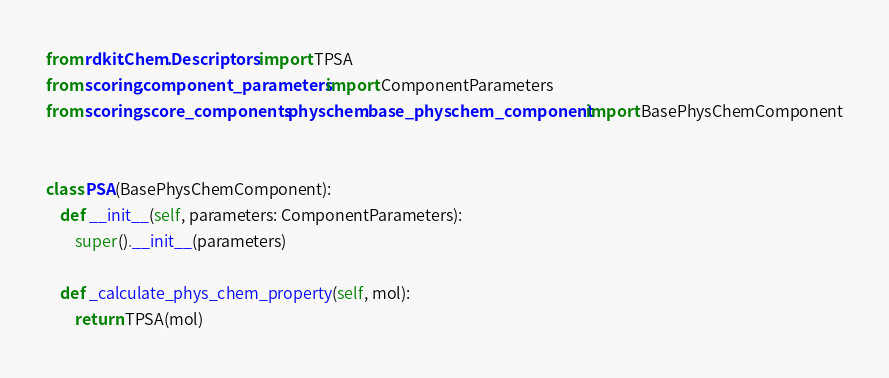<code> <loc_0><loc_0><loc_500><loc_500><_Python_>from rdkit.Chem.Descriptors import TPSA
from scoring.component_parameters import ComponentParameters
from scoring.score_components.physchem.base_physchem_component import BasePhysChemComponent


class PSA(BasePhysChemComponent):
    def __init__(self, parameters: ComponentParameters):
        super().__init__(parameters)

    def _calculate_phys_chem_property(self, mol):
        return TPSA(mol)
</code> 